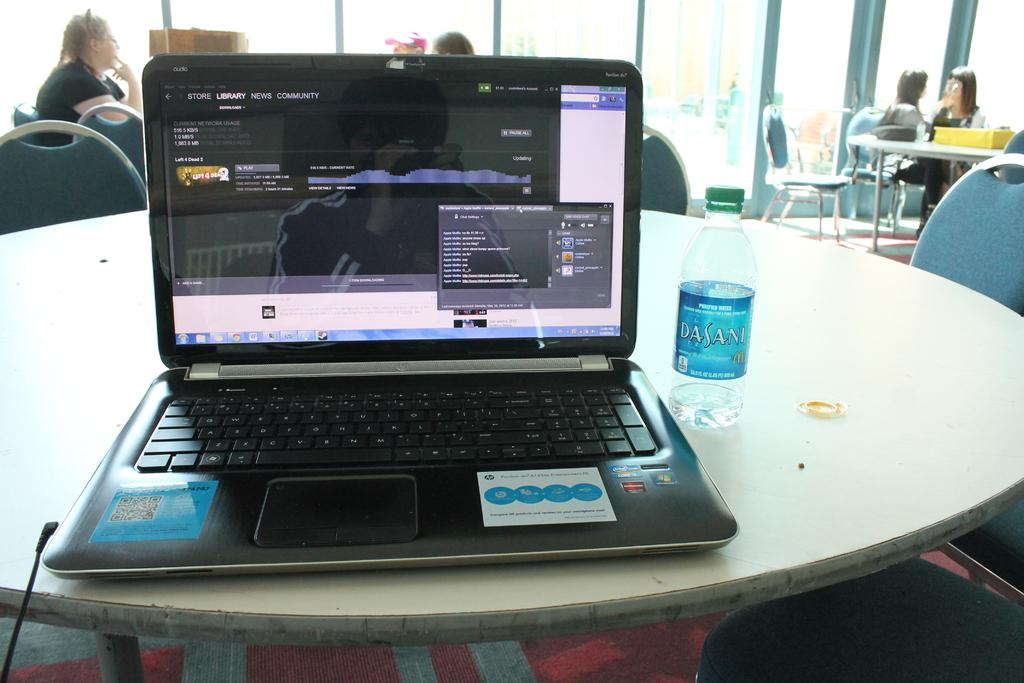Provide a one-sentence caption for the provided image. A laptop viewing an online community news website. 